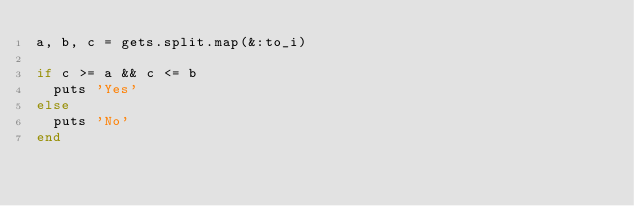Convert code to text. <code><loc_0><loc_0><loc_500><loc_500><_Ruby_>a, b, c = gets.split.map(&:to_i)

if c >= a && c <= b
  puts 'Yes'
else
  puts 'No'
end</code> 